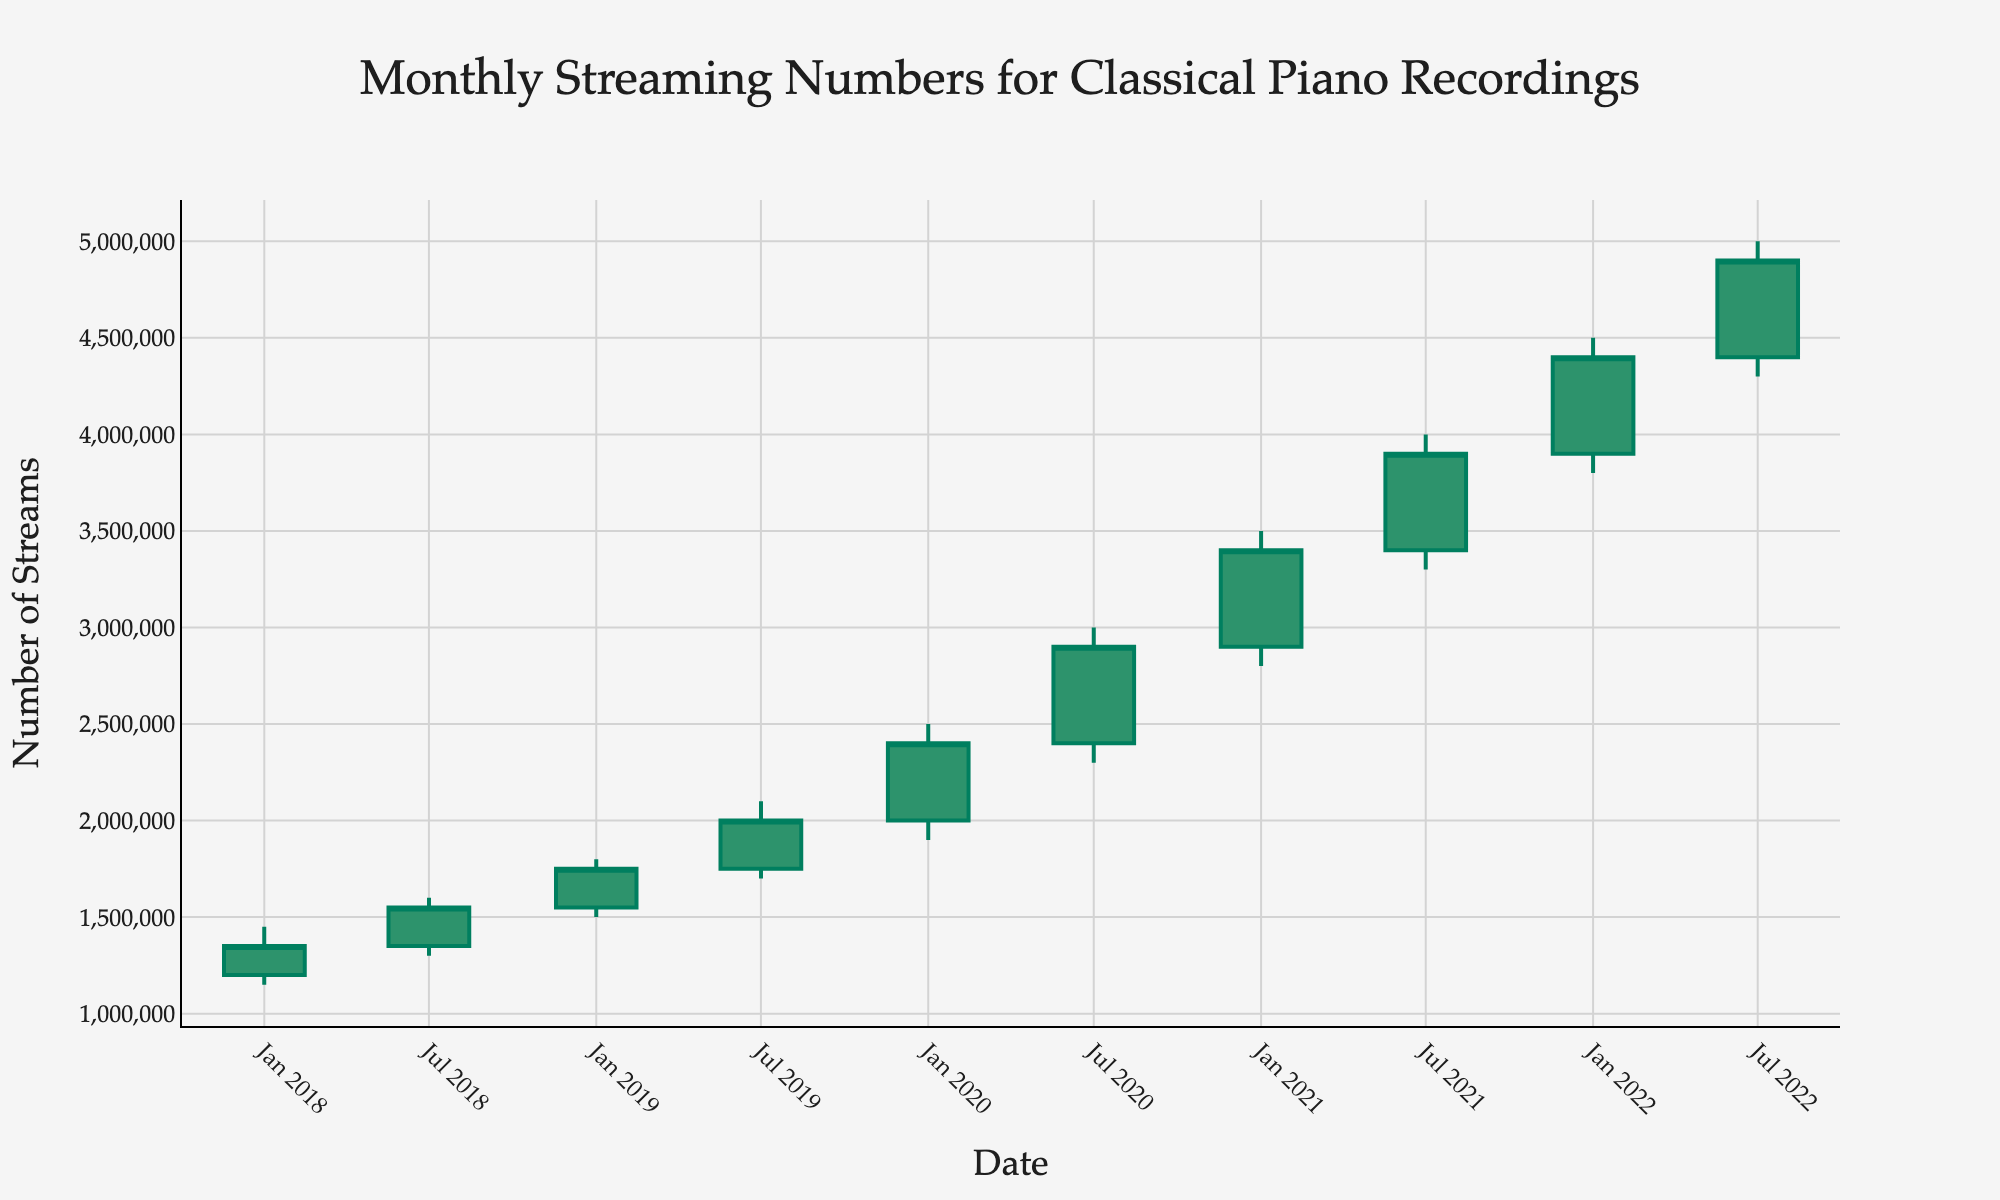What is the title of the OHLC chart? The title is located at the top center of the chart in a larger font size and a specific font style. It describes the overall subject of the data.
Answer: Monthly Streaming Numbers for Classical Piano Recordings What does the y-axis represent in the chart? The y-axis title is located on the left side of the chart and it describes the measurement used for the vertical axis values.
Answer: Number of Streams What is the range of months included in the x-axis? The x-axis plots the Date from left to right, starting from the earliest point and ending with the most recent one.
Answer: January 2018 to July 2022 What was the highest number of streams recorded in any month? The highest value can be found by identifying the tallest point in the chart, which corresponds to the 'High' column from the data.
Answer: 5,000,000 How did the number of streams change from January 2020 to July 2020? To determine the change, compare the 'Close' value of January 2020 with the 'Close' value of July 2020. Subtract January's value from July's value.
Answer: Increased by 500,000 What was the trend in the number of streams from January 2018 to July 2022? Observing the overall direction of the 'Close' prices from the start to the end of the dataset, we notice whether it generally rises or falls.
Answer: Increasing trend Between which consecutive months did the number of streams decrease the most? To find this, compare all pairs of consecutive 'Close' values to see which has the largest negative difference. Look for rapid downward transitions.
Answer: No months showed a decrease; all consecutive months have an increase Which month had the largest gap between the high and low number of streams? The largest gap is the difference between 'High' and 'Low' values for each month. Calculate these gaps and find the maximum one.
Answer: January 2020 How much did the number of streams change from the highest point to the lowest point in July 2020? Identify the 'High' and 'Low' values for July 2020, then subtract the lower value from the higher value to find the change.
Answer: 700,000 In which month did the number of streams first exceed 2.5 million? Detect the first occurrence when the 'Close' value surpasses 2.5 million by inspecting the sequence of months in the chart.
Answer: January 2020 